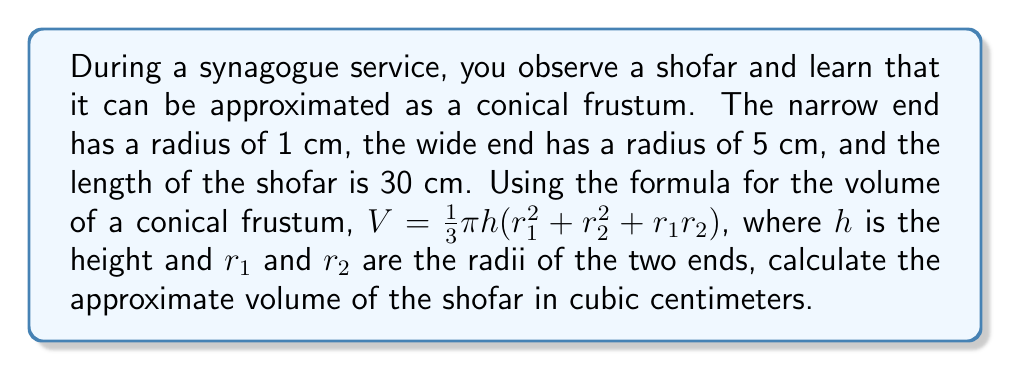Provide a solution to this math problem. Let's approach this step-by-step:

1) We are given:
   $r_1 = 1$ cm (radius of the narrow end)
   $r_2 = 5$ cm (radius of the wide end)
   $h = 30$ cm (length of the shofar)

2) The formula for the volume of a conical frustum is:
   $V = \frac{1}{3}\pi h(r_1^2 + r_2^2 + r_1r_2)$

3) Let's substitute our known values:
   $V = \frac{1}{3}\pi \cdot 30(1^2 + 5^2 + 1 \cdot 5)$

4) Simplify inside the parentheses:
   $V = \frac{1}{3}\pi \cdot 30(1 + 25 + 5)$
   $V = \frac{1}{3}\pi \cdot 30(31)$

5) Multiply:
   $V = 10\pi \cdot 31$
   $V = 310\pi$

6) This gives us the exact volume in terms of $\pi$. To get a decimal approximation, we can use $\pi \approx 3.14159$:
   $V \approx 310 \cdot 3.14159 \approx 973.89$ cm³

Therefore, the approximate volume of the shofar is 973.89 cubic centimeters.
Answer: $310\pi$ cm³ or approximately 973.89 cm³ 